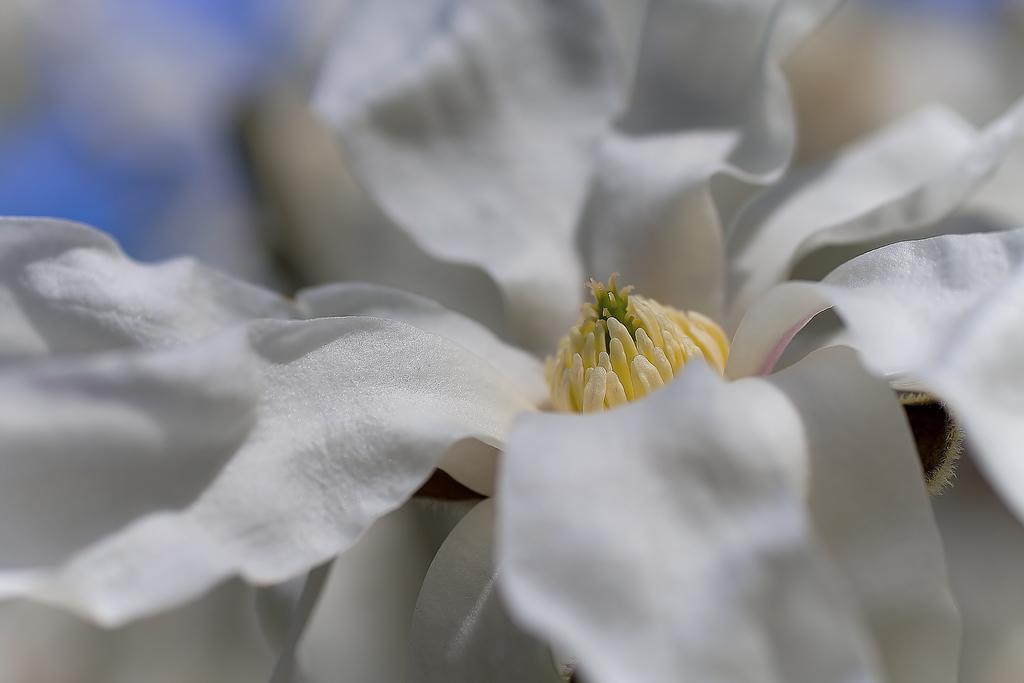Could you give a brief overview of what you see in this image? In this image, we can see a flower which is in white color. In the left corner, we can see blue color. 